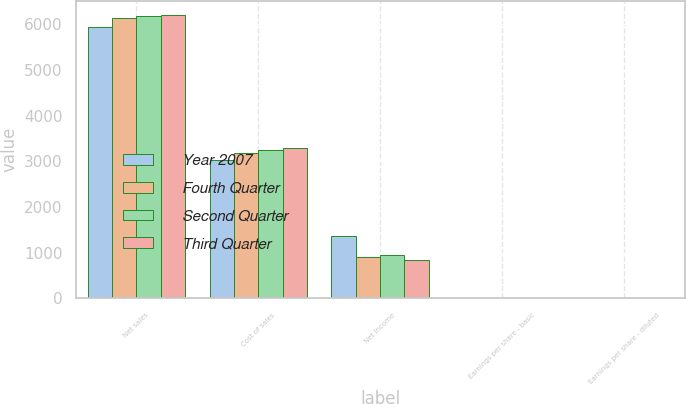Convert chart to OTSL. <chart><loc_0><loc_0><loc_500><loc_500><stacked_bar_chart><ecel><fcel>Net sales<fcel>Cost of sales<fcel>Net income<fcel>Earnings per share - basic<fcel>Earnings per share - diluted<nl><fcel>Year 2007<fcel>5937<fcel>3022<fcel>1368<fcel>1.88<fcel>1.85<nl><fcel>Fourth Quarter<fcel>6142<fcel>3175<fcel>917<fcel>1.28<fcel>1.25<nl><fcel>Second Quarter<fcel>6177<fcel>3240<fcel>960<fcel>1.34<fcel>1.32<nl><fcel>Third Quarter<fcel>6206<fcel>3298<fcel>851<fcel>1.2<fcel>1.17<nl></chart> 